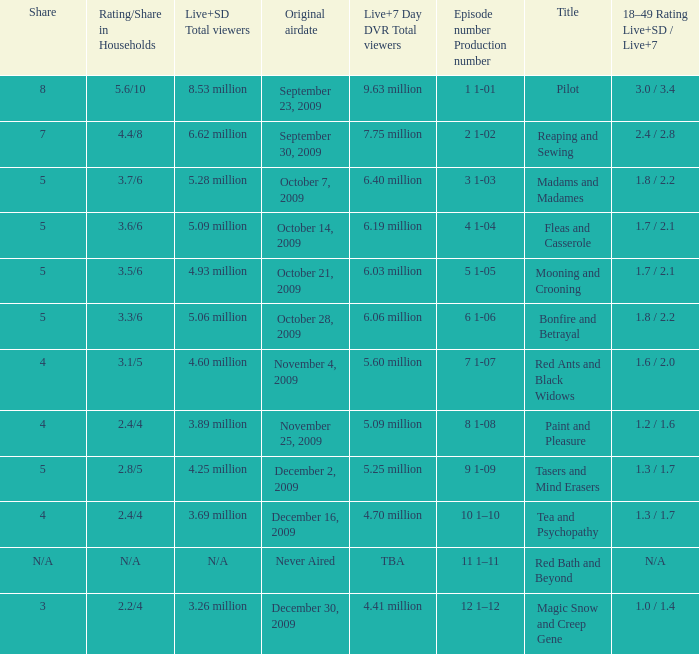When did the episode that had 5.09 million total viewers (both Live and SD types) first air? October 14, 2009. 